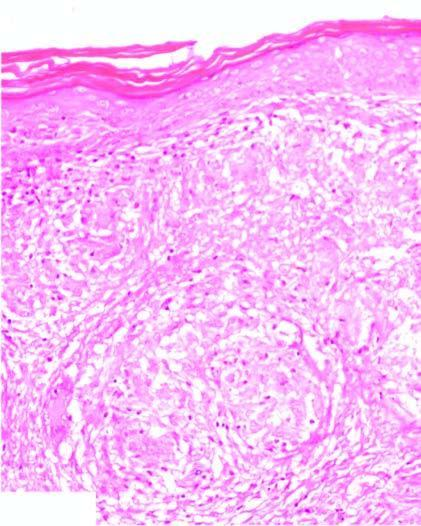what does the dermis show?
Answer the question using a single word or phrase. Noncaseating epithelioid granulomas having langhans' giant cells and paucity of lymphocytes 